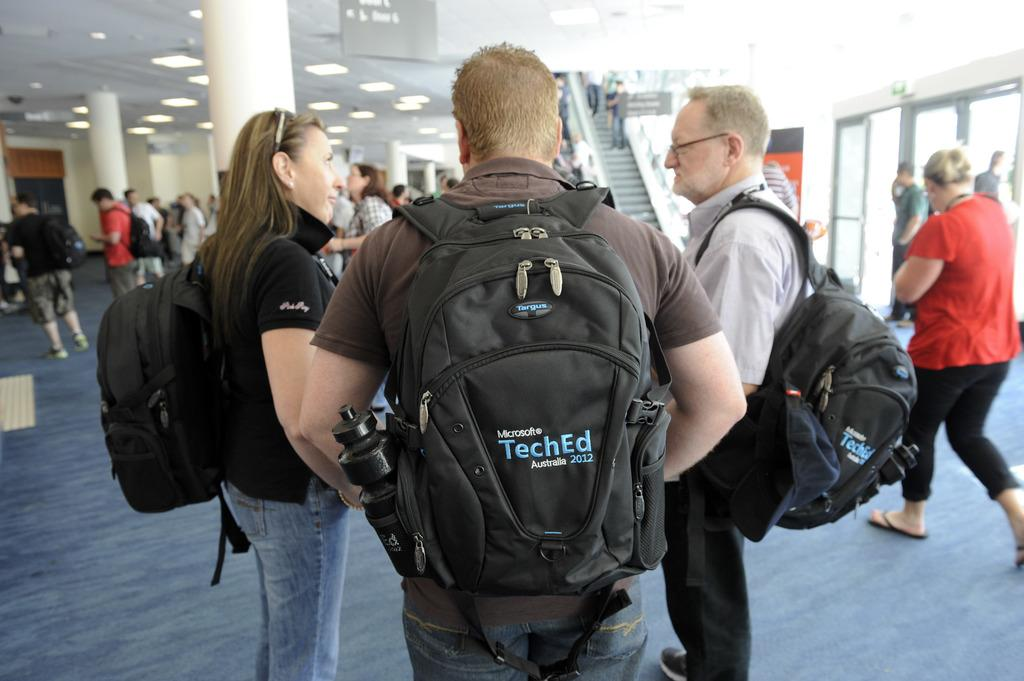<image>
Render a clear and concise summary of the photo. Several people wear Microsoft backpacks at a convention. 